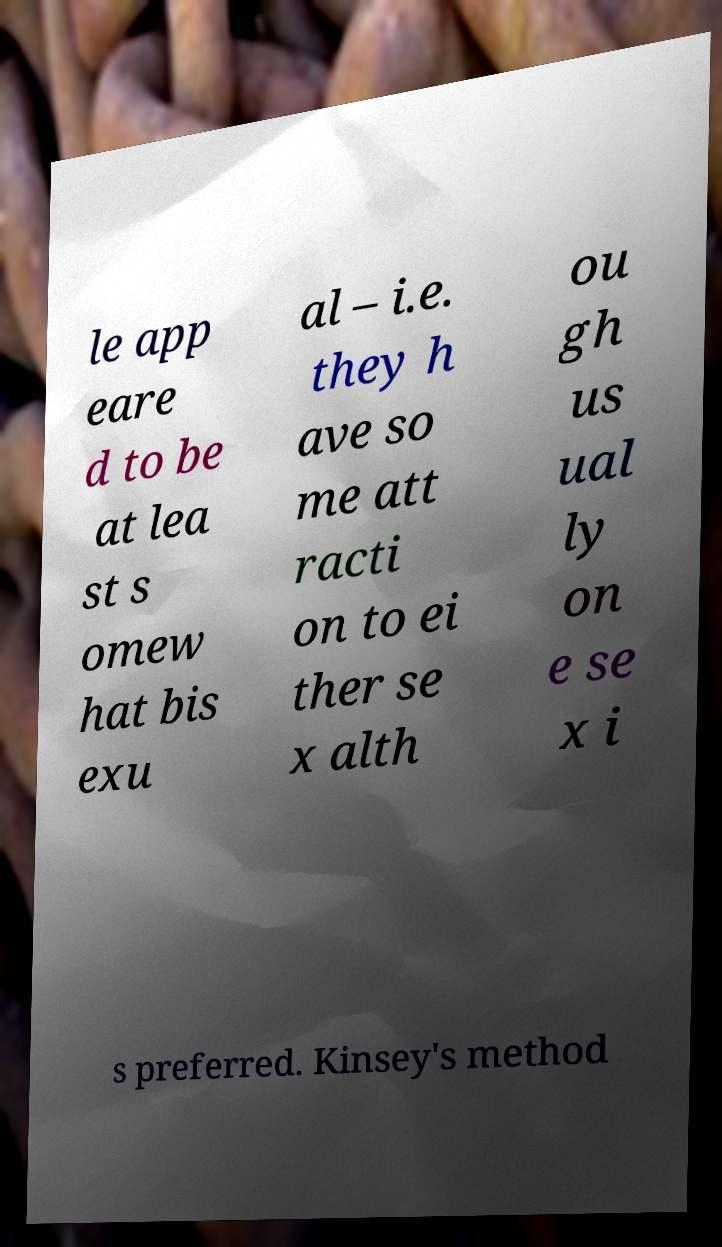Please identify and transcribe the text found in this image. le app eare d to be at lea st s omew hat bis exu al – i.e. they h ave so me att racti on to ei ther se x alth ou gh us ual ly on e se x i s preferred. Kinsey's method 